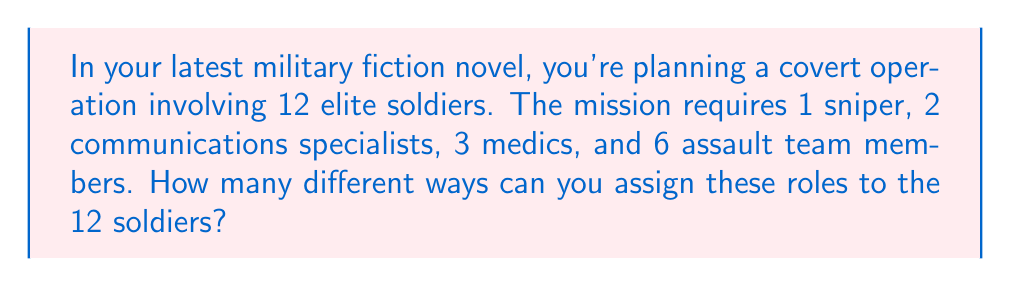Can you answer this question? Let's approach this step-by-step using the multiplication principle of counting:

1) First, we need to choose 1 sniper from 12 soldiers:
   $${12 \choose 1} = 12$$ ways

2) After assigning the sniper, we have 11 soldiers left. We need to choose 2 communications specialists from these 11:
   $${11 \choose 2} = 55$$ ways

3) Now we have 9 soldiers left, from which we need to choose 3 medics:
   $${9 \choose 3} = 84$$ ways

4) The remaining 6 soldiers will automatically become the assault team members.

5) According to the multiplication principle, the total number of ways to assign these roles is the product of the number of ways for each individual assignment:

   $$12 \times 55 \times 84 = 55,440$$

Alternatively, we can express this using the multinomial coefficient:

$$\frac{12!}{1!2!3!6!} = 55,440$$

This formula directly calculates the number of ways to divide 12 distinct objects into groups of 1, 2, 3, and 6.
Answer: 55,440 